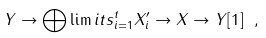Convert formula to latex. <formula><loc_0><loc_0><loc_500><loc_500>Y \to \bigoplus \lim i t s _ { i = 1 } ^ { t } X ^ { \prime } _ { i } \to X \to Y [ 1 ] \ ,</formula> 